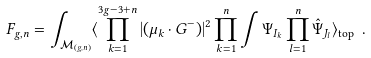<formula> <loc_0><loc_0><loc_500><loc_500>F _ { g , n } = \int _ { \mathcal { M } _ { ( g , n ) } } \langle \prod _ { k = 1 } ^ { 3 g - 3 + n } | ( \mu _ { k } \cdot G ^ { - } ) | ^ { 2 } \prod _ { k = 1 } ^ { n } \int \Psi _ { I _ { k } } \prod _ { l = 1 } ^ { n } \hat { \Psi } _ { J _ { l } } \rangle _ { \text {top} } \ .</formula> 